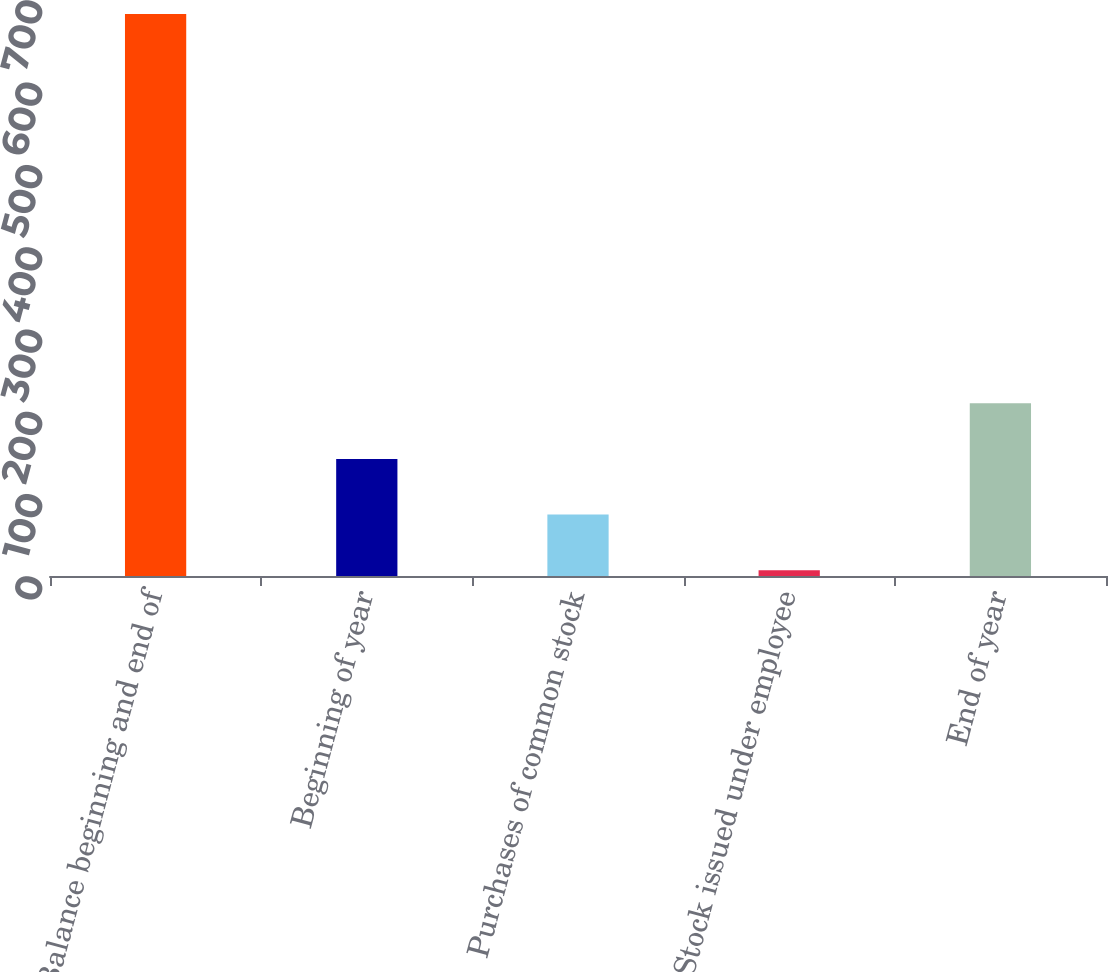Convert chart to OTSL. <chart><loc_0><loc_0><loc_500><loc_500><bar_chart><fcel>Balance beginning and end of<fcel>Beginning of year<fcel>Purchases of common stock<fcel>Stock issued under employee<fcel>End of year<nl><fcel>683<fcel>142.2<fcel>74.6<fcel>7<fcel>209.8<nl></chart> 